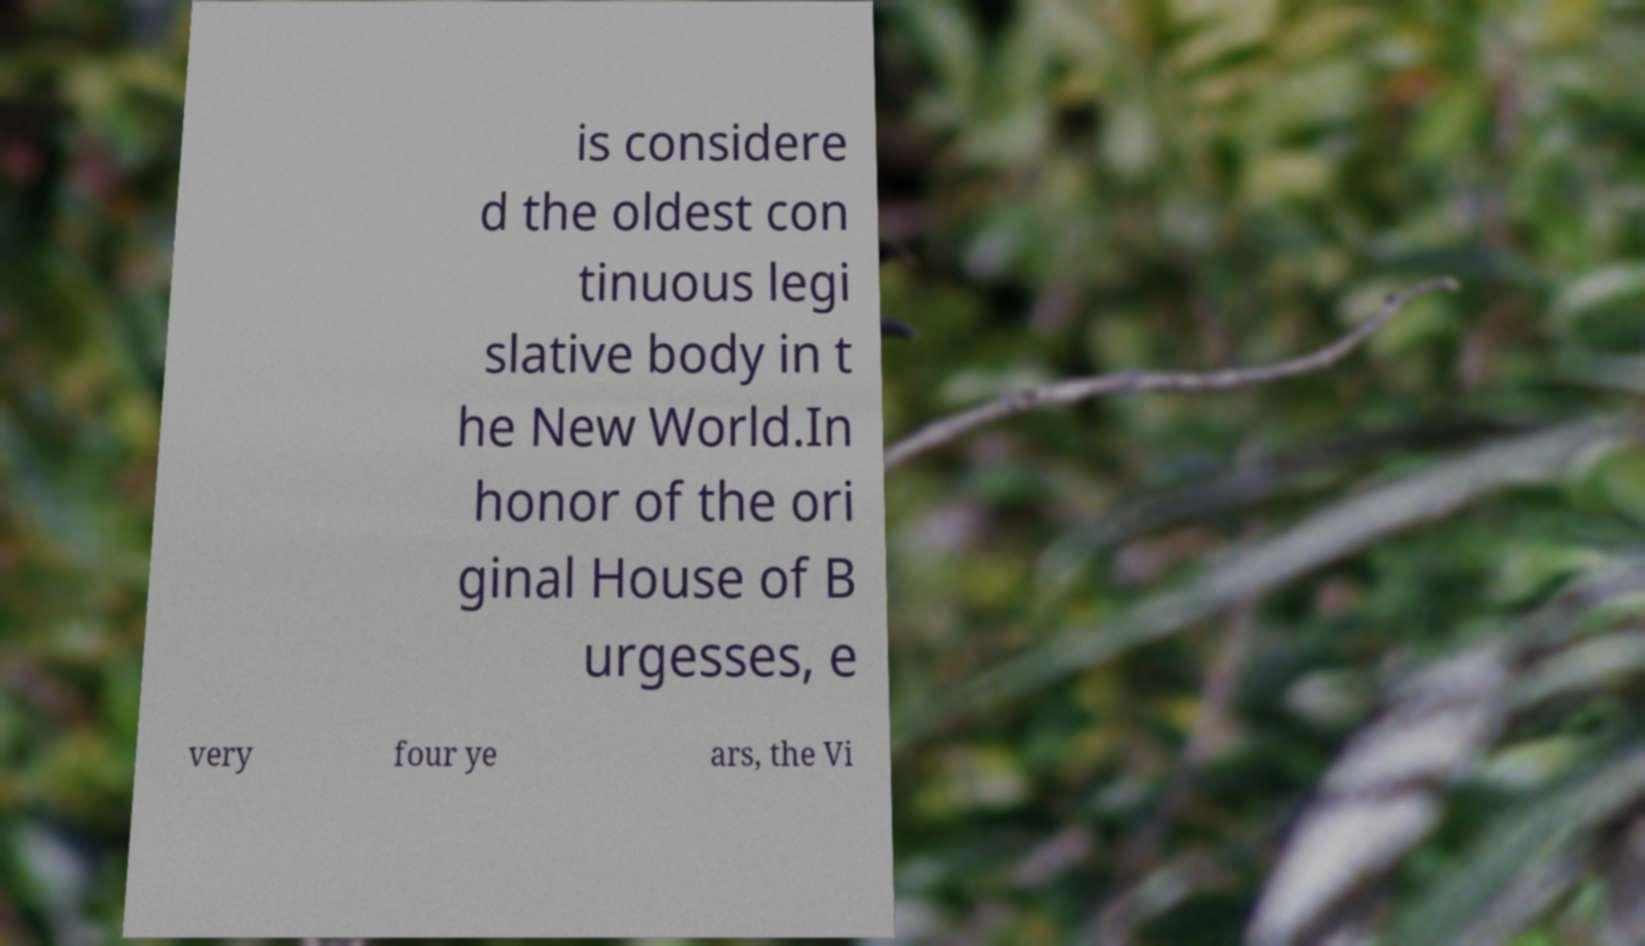I need the written content from this picture converted into text. Can you do that? is considere d the oldest con tinuous legi slative body in t he New World.In honor of the ori ginal House of B urgesses, e very four ye ars, the Vi 